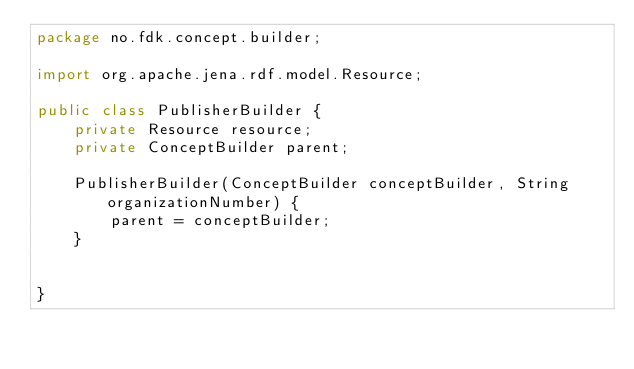Convert code to text. <code><loc_0><loc_0><loc_500><loc_500><_Java_>package no.fdk.concept.builder;

import org.apache.jena.rdf.model.Resource;

public class PublisherBuilder {
    private Resource resource;
    private ConceptBuilder parent;

    PublisherBuilder(ConceptBuilder conceptBuilder, String organizationNumber) {
        parent = conceptBuilder;
    }


}
</code> 